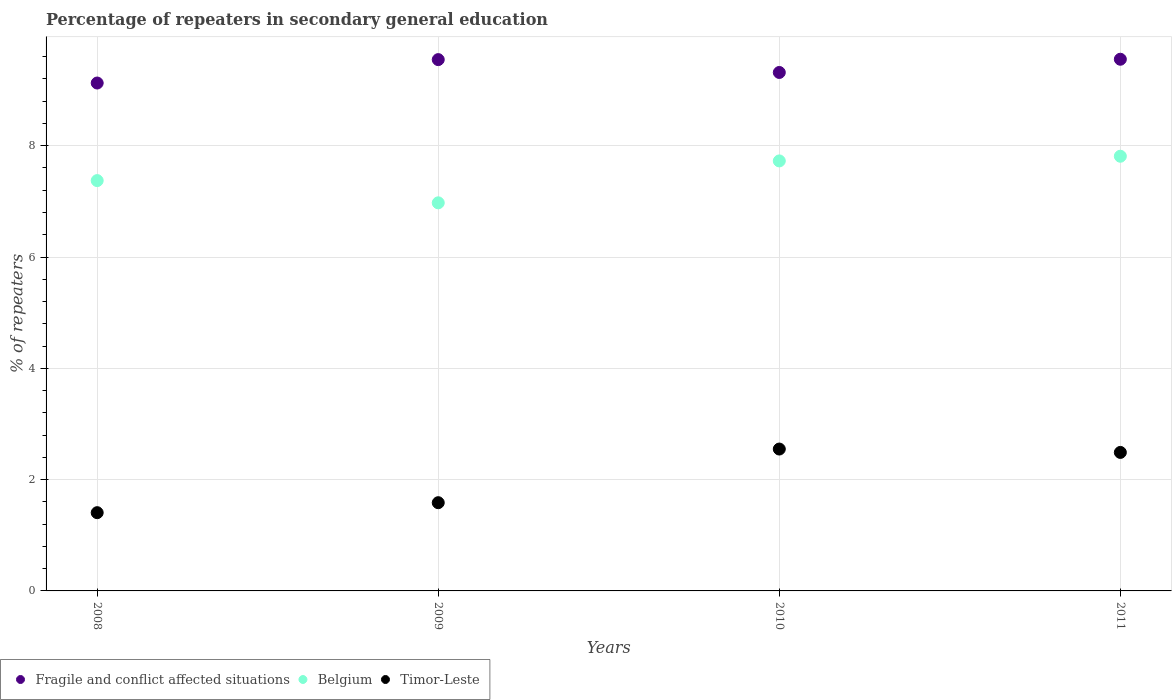How many different coloured dotlines are there?
Your answer should be very brief. 3. What is the percentage of repeaters in secondary general education in Timor-Leste in 2009?
Your answer should be very brief. 1.59. Across all years, what is the maximum percentage of repeaters in secondary general education in Belgium?
Provide a short and direct response. 7.81. Across all years, what is the minimum percentage of repeaters in secondary general education in Belgium?
Your answer should be very brief. 6.97. In which year was the percentage of repeaters in secondary general education in Timor-Leste maximum?
Make the answer very short. 2010. In which year was the percentage of repeaters in secondary general education in Fragile and conflict affected situations minimum?
Provide a succinct answer. 2008. What is the total percentage of repeaters in secondary general education in Belgium in the graph?
Offer a terse response. 29.89. What is the difference between the percentage of repeaters in secondary general education in Fragile and conflict affected situations in 2009 and that in 2011?
Keep it short and to the point. -0.01. What is the difference between the percentage of repeaters in secondary general education in Timor-Leste in 2009 and the percentage of repeaters in secondary general education in Fragile and conflict affected situations in 2010?
Your answer should be very brief. -7.73. What is the average percentage of repeaters in secondary general education in Belgium per year?
Provide a short and direct response. 7.47. In the year 2009, what is the difference between the percentage of repeaters in secondary general education in Belgium and percentage of repeaters in secondary general education in Fragile and conflict affected situations?
Offer a terse response. -2.57. In how many years, is the percentage of repeaters in secondary general education in Fragile and conflict affected situations greater than 6.8 %?
Make the answer very short. 4. What is the ratio of the percentage of repeaters in secondary general education in Fragile and conflict affected situations in 2008 to that in 2011?
Your answer should be compact. 0.96. Is the percentage of repeaters in secondary general education in Timor-Leste in 2008 less than that in 2009?
Your response must be concise. Yes. Is the difference between the percentage of repeaters in secondary general education in Belgium in 2008 and 2009 greater than the difference between the percentage of repeaters in secondary general education in Fragile and conflict affected situations in 2008 and 2009?
Offer a terse response. Yes. What is the difference between the highest and the second highest percentage of repeaters in secondary general education in Belgium?
Give a very brief answer. 0.08. What is the difference between the highest and the lowest percentage of repeaters in secondary general education in Belgium?
Offer a very short reply. 0.84. Is it the case that in every year, the sum of the percentage of repeaters in secondary general education in Belgium and percentage of repeaters in secondary general education in Timor-Leste  is greater than the percentage of repeaters in secondary general education in Fragile and conflict affected situations?
Keep it short and to the point. No. Does the percentage of repeaters in secondary general education in Timor-Leste monotonically increase over the years?
Your response must be concise. No. Is the percentage of repeaters in secondary general education in Belgium strictly less than the percentage of repeaters in secondary general education in Fragile and conflict affected situations over the years?
Your answer should be compact. Yes. How many years are there in the graph?
Give a very brief answer. 4. What is the difference between two consecutive major ticks on the Y-axis?
Offer a terse response. 2. Are the values on the major ticks of Y-axis written in scientific E-notation?
Keep it short and to the point. No. Does the graph contain grids?
Your answer should be very brief. Yes. How are the legend labels stacked?
Your response must be concise. Horizontal. What is the title of the graph?
Ensure brevity in your answer.  Percentage of repeaters in secondary general education. Does "Kiribati" appear as one of the legend labels in the graph?
Offer a terse response. No. What is the label or title of the Y-axis?
Make the answer very short. % of repeaters. What is the % of repeaters in Fragile and conflict affected situations in 2008?
Offer a very short reply. 9.13. What is the % of repeaters of Belgium in 2008?
Keep it short and to the point. 7.37. What is the % of repeaters in Timor-Leste in 2008?
Offer a terse response. 1.41. What is the % of repeaters in Fragile and conflict affected situations in 2009?
Your answer should be compact. 9.55. What is the % of repeaters in Belgium in 2009?
Make the answer very short. 6.97. What is the % of repeaters of Timor-Leste in 2009?
Keep it short and to the point. 1.59. What is the % of repeaters of Fragile and conflict affected situations in 2010?
Ensure brevity in your answer.  9.32. What is the % of repeaters of Belgium in 2010?
Provide a succinct answer. 7.73. What is the % of repeaters in Timor-Leste in 2010?
Provide a short and direct response. 2.55. What is the % of repeaters of Fragile and conflict affected situations in 2011?
Provide a succinct answer. 9.55. What is the % of repeaters in Belgium in 2011?
Your response must be concise. 7.81. What is the % of repeaters of Timor-Leste in 2011?
Your answer should be very brief. 2.49. Across all years, what is the maximum % of repeaters of Fragile and conflict affected situations?
Your answer should be very brief. 9.55. Across all years, what is the maximum % of repeaters in Belgium?
Ensure brevity in your answer.  7.81. Across all years, what is the maximum % of repeaters of Timor-Leste?
Offer a terse response. 2.55. Across all years, what is the minimum % of repeaters in Fragile and conflict affected situations?
Your response must be concise. 9.13. Across all years, what is the minimum % of repeaters of Belgium?
Offer a very short reply. 6.97. Across all years, what is the minimum % of repeaters of Timor-Leste?
Give a very brief answer. 1.41. What is the total % of repeaters of Fragile and conflict affected situations in the graph?
Provide a succinct answer. 37.55. What is the total % of repeaters in Belgium in the graph?
Your response must be concise. 29.89. What is the total % of repeaters in Timor-Leste in the graph?
Your response must be concise. 8.03. What is the difference between the % of repeaters of Fragile and conflict affected situations in 2008 and that in 2009?
Ensure brevity in your answer.  -0.42. What is the difference between the % of repeaters in Belgium in 2008 and that in 2009?
Ensure brevity in your answer.  0.4. What is the difference between the % of repeaters of Timor-Leste in 2008 and that in 2009?
Ensure brevity in your answer.  -0.18. What is the difference between the % of repeaters of Fragile and conflict affected situations in 2008 and that in 2010?
Your response must be concise. -0.19. What is the difference between the % of repeaters of Belgium in 2008 and that in 2010?
Your answer should be very brief. -0.35. What is the difference between the % of repeaters of Timor-Leste in 2008 and that in 2010?
Your answer should be compact. -1.14. What is the difference between the % of repeaters of Fragile and conflict affected situations in 2008 and that in 2011?
Provide a succinct answer. -0.43. What is the difference between the % of repeaters of Belgium in 2008 and that in 2011?
Make the answer very short. -0.44. What is the difference between the % of repeaters in Timor-Leste in 2008 and that in 2011?
Offer a terse response. -1.08. What is the difference between the % of repeaters of Fragile and conflict affected situations in 2009 and that in 2010?
Offer a terse response. 0.23. What is the difference between the % of repeaters in Belgium in 2009 and that in 2010?
Make the answer very short. -0.75. What is the difference between the % of repeaters in Timor-Leste in 2009 and that in 2010?
Offer a terse response. -0.96. What is the difference between the % of repeaters in Fragile and conflict affected situations in 2009 and that in 2011?
Make the answer very short. -0.01. What is the difference between the % of repeaters of Belgium in 2009 and that in 2011?
Make the answer very short. -0.84. What is the difference between the % of repeaters of Timor-Leste in 2009 and that in 2011?
Offer a terse response. -0.9. What is the difference between the % of repeaters in Fragile and conflict affected situations in 2010 and that in 2011?
Your response must be concise. -0.24. What is the difference between the % of repeaters of Belgium in 2010 and that in 2011?
Offer a terse response. -0.08. What is the difference between the % of repeaters of Timor-Leste in 2010 and that in 2011?
Ensure brevity in your answer.  0.06. What is the difference between the % of repeaters of Fragile and conflict affected situations in 2008 and the % of repeaters of Belgium in 2009?
Offer a very short reply. 2.15. What is the difference between the % of repeaters of Fragile and conflict affected situations in 2008 and the % of repeaters of Timor-Leste in 2009?
Ensure brevity in your answer.  7.54. What is the difference between the % of repeaters of Belgium in 2008 and the % of repeaters of Timor-Leste in 2009?
Provide a short and direct response. 5.79. What is the difference between the % of repeaters of Fragile and conflict affected situations in 2008 and the % of repeaters of Belgium in 2010?
Provide a short and direct response. 1.4. What is the difference between the % of repeaters of Fragile and conflict affected situations in 2008 and the % of repeaters of Timor-Leste in 2010?
Your response must be concise. 6.58. What is the difference between the % of repeaters in Belgium in 2008 and the % of repeaters in Timor-Leste in 2010?
Your response must be concise. 4.82. What is the difference between the % of repeaters of Fragile and conflict affected situations in 2008 and the % of repeaters of Belgium in 2011?
Provide a succinct answer. 1.32. What is the difference between the % of repeaters of Fragile and conflict affected situations in 2008 and the % of repeaters of Timor-Leste in 2011?
Your answer should be compact. 6.64. What is the difference between the % of repeaters in Belgium in 2008 and the % of repeaters in Timor-Leste in 2011?
Ensure brevity in your answer.  4.88. What is the difference between the % of repeaters in Fragile and conflict affected situations in 2009 and the % of repeaters in Belgium in 2010?
Offer a very short reply. 1.82. What is the difference between the % of repeaters in Fragile and conflict affected situations in 2009 and the % of repeaters in Timor-Leste in 2010?
Keep it short and to the point. 7. What is the difference between the % of repeaters of Belgium in 2009 and the % of repeaters of Timor-Leste in 2010?
Your answer should be compact. 4.42. What is the difference between the % of repeaters of Fragile and conflict affected situations in 2009 and the % of repeaters of Belgium in 2011?
Make the answer very short. 1.74. What is the difference between the % of repeaters of Fragile and conflict affected situations in 2009 and the % of repeaters of Timor-Leste in 2011?
Provide a succinct answer. 7.06. What is the difference between the % of repeaters of Belgium in 2009 and the % of repeaters of Timor-Leste in 2011?
Your answer should be compact. 4.49. What is the difference between the % of repeaters of Fragile and conflict affected situations in 2010 and the % of repeaters of Belgium in 2011?
Your answer should be compact. 1.51. What is the difference between the % of repeaters of Fragile and conflict affected situations in 2010 and the % of repeaters of Timor-Leste in 2011?
Offer a very short reply. 6.83. What is the difference between the % of repeaters in Belgium in 2010 and the % of repeaters in Timor-Leste in 2011?
Offer a terse response. 5.24. What is the average % of repeaters of Fragile and conflict affected situations per year?
Give a very brief answer. 9.39. What is the average % of repeaters in Belgium per year?
Ensure brevity in your answer.  7.47. What is the average % of repeaters in Timor-Leste per year?
Offer a terse response. 2.01. In the year 2008, what is the difference between the % of repeaters of Fragile and conflict affected situations and % of repeaters of Belgium?
Provide a succinct answer. 1.75. In the year 2008, what is the difference between the % of repeaters in Fragile and conflict affected situations and % of repeaters in Timor-Leste?
Provide a short and direct response. 7.72. In the year 2008, what is the difference between the % of repeaters of Belgium and % of repeaters of Timor-Leste?
Provide a short and direct response. 5.97. In the year 2009, what is the difference between the % of repeaters of Fragile and conflict affected situations and % of repeaters of Belgium?
Ensure brevity in your answer.  2.57. In the year 2009, what is the difference between the % of repeaters of Fragile and conflict affected situations and % of repeaters of Timor-Leste?
Your response must be concise. 7.96. In the year 2009, what is the difference between the % of repeaters in Belgium and % of repeaters in Timor-Leste?
Provide a succinct answer. 5.39. In the year 2010, what is the difference between the % of repeaters of Fragile and conflict affected situations and % of repeaters of Belgium?
Give a very brief answer. 1.59. In the year 2010, what is the difference between the % of repeaters in Fragile and conflict affected situations and % of repeaters in Timor-Leste?
Provide a succinct answer. 6.77. In the year 2010, what is the difference between the % of repeaters of Belgium and % of repeaters of Timor-Leste?
Your answer should be compact. 5.18. In the year 2011, what is the difference between the % of repeaters of Fragile and conflict affected situations and % of repeaters of Belgium?
Provide a short and direct response. 1.74. In the year 2011, what is the difference between the % of repeaters in Fragile and conflict affected situations and % of repeaters in Timor-Leste?
Give a very brief answer. 7.07. In the year 2011, what is the difference between the % of repeaters of Belgium and % of repeaters of Timor-Leste?
Your response must be concise. 5.32. What is the ratio of the % of repeaters of Fragile and conflict affected situations in 2008 to that in 2009?
Offer a very short reply. 0.96. What is the ratio of the % of repeaters of Belgium in 2008 to that in 2009?
Provide a succinct answer. 1.06. What is the ratio of the % of repeaters in Timor-Leste in 2008 to that in 2009?
Provide a succinct answer. 0.89. What is the ratio of the % of repeaters of Fragile and conflict affected situations in 2008 to that in 2010?
Keep it short and to the point. 0.98. What is the ratio of the % of repeaters of Belgium in 2008 to that in 2010?
Offer a terse response. 0.95. What is the ratio of the % of repeaters of Timor-Leste in 2008 to that in 2010?
Provide a short and direct response. 0.55. What is the ratio of the % of repeaters in Fragile and conflict affected situations in 2008 to that in 2011?
Offer a very short reply. 0.96. What is the ratio of the % of repeaters in Belgium in 2008 to that in 2011?
Give a very brief answer. 0.94. What is the ratio of the % of repeaters in Timor-Leste in 2008 to that in 2011?
Your response must be concise. 0.56. What is the ratio of the % of repeaters of Fragile and conflict affected situations in 2009 to that in 2010?
Provide a short and direct response. 1.02. What is the ratio of the % of repeaters in Belgium in 2009 to that in 2010?
Provide a succinct answer. 0.9. What is the ratio of the % of repeaters in Timor-Leste in 2009 to that in 2010?
Ensure brevity in your answer.  0.62. What is the ratio of the % of repeaters in Belgium in 2009 to that in 2011?
Your answer should be compact. 0.89. What is the ratio of the % of repeaters of Timor-Leste in 2009 to that in 2011?
Your answer should be compact. 0.64. What is the ratio of the % of repeaters in Fragile and conflict affected situations in 2010 to that in 2011?
Offer a very short reply. 0.98. What is the ratio of the % of repeaters in Belgium in 2010 to that in 2011?
Keep it short and to the point. 0.99. What is the ratio of the % of repeaters in Timor-Leste in 2010 to that in 2011?
Give a very brief answer. 1.02. What is the difference between the highest and the second highest % of repeaters of Fragile and conflict affected situations?
Your response must be concise. 0.01. What is the difference between the highest and the second highest % of repeaters in Belgium?
Give a very brief answer. 0.08. What is the difference between the highest and the second highest % of repeaters of Timor-Leste?
Keep it short and to the point. 0.06. What is the difference between the highest and the lowest % of repeaters of Fragile and conflict affected situations?
Provide a succinct answer. 0.43. What is the difference between the highest and the lowest % of repeaters of Belgium?
Your answer should be very brief. 0.84. What is the difference between the highest and the lowest % of repeaters of Timor-Leste?
Your response must be concise. 1.14. 